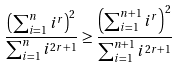<formula> <loc_0><loc_0><loc_500><loc_500>\frac { \left ( \sum ^ { n } _ { i = 1 } i ^ { r } \right ) ^ { 2 } } { \sum ^ { n } _ { i = 1 } i ^ { 2 r + 1 } } \geq \frac { \left ( \sum ^ { n + 1 } _ { i = 1 } i ^ { r } \right ) ^ { 2 } } { \sum ^ { n + 1 } _ { i = 1 } i ^ { 2 r + 1 } }</formula> 